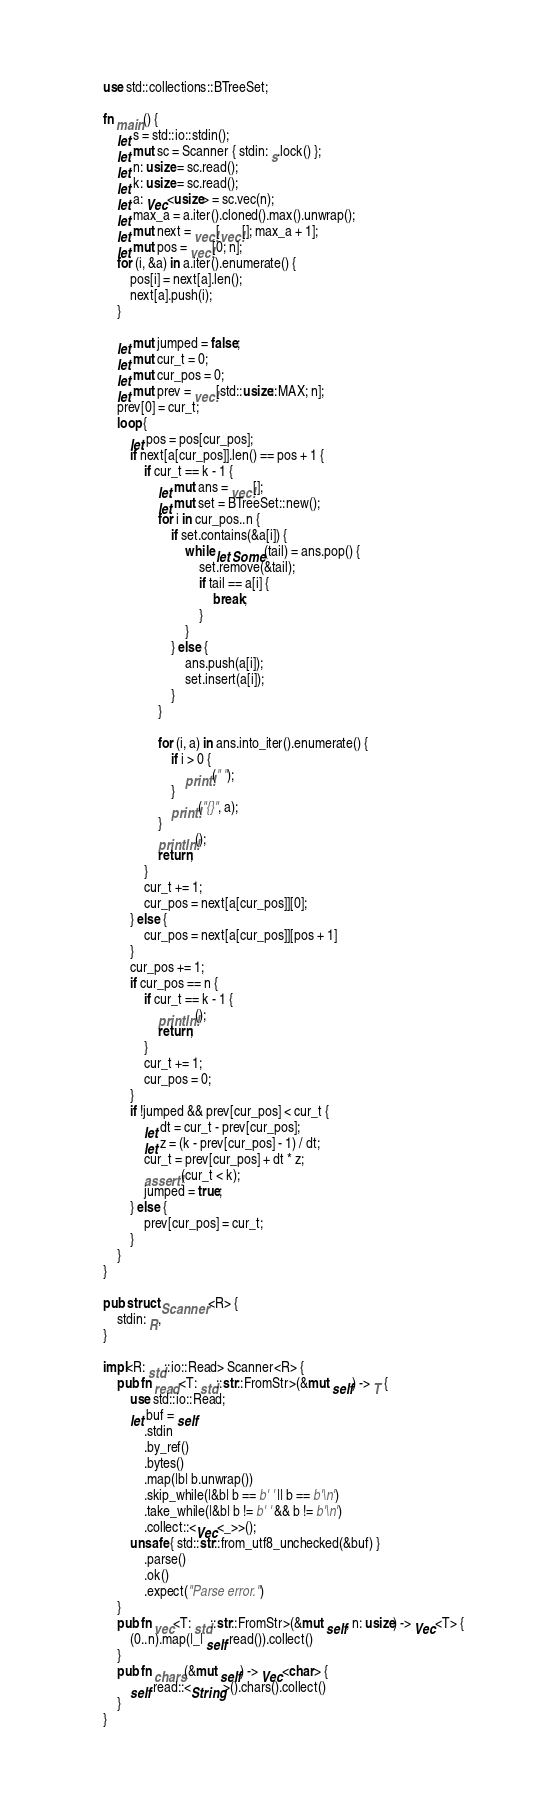Convert code to text. <code><loc_0><loc_0><loc_500><loc_500><_Rust_>use std::collections::BTreeSet;

fn main() {
    let s = std::io::stdin();
    let mut sc = Scanner { stdin: s.lock() };
    let n: usize = sc.read();
    let k: usize = sc.read();
    let a: Vec<usize> = sc.vec(n);
    let max_a = a.iter().cloned().max().unwrap();
    let mut next = vec![vec![]; max_a + 1];
    let mut pos = vec![0; n];
    for (i, &a) in a.iter().enumerate() {
        pos[i] = next[a].len();
        next[a].push(i);
    }

    let mut jumped = false;
    let mut cur_t = 0;
    let mut cur_pos = 0;
    let mut prev = vec![std::usize::MAX; n];
    prev[0] = cur_t;
    loop {
        let pos = pos[cur_pos];
        if next[a[cur_pos]].len() == pos + 1 {
            if cur_t == k - 1 {
                let mut ans = vec![];
                let mut set = BTreeSet::new();
                for i in cur_pos..n {
                    if set.contains(&a[i]) {
                        while let Some(tail) = ans.pop() {
                            set.remove(&tail);
                            if tail == a[i] {
                                break;
                            }
                        }
                    } else {
                        ans.push(a[i]);
                        set.insert(a[i]);
                    }
                }

                for (i, a) in ans.into_iter().enumerate() {
                    if i > 0 {
                        print!(" ");
                    }
                    print!("{}", a);
                }
                println!();
                return;
            }
            cur_t += 1;
            cur_pos = next[a[cur_pos]][0];
        } else {
            cur_pos = next[a[cur_pos]][pos + 1]
        }
        cur_pos += 1;
        if cur_pos == n {
            if cur_t == k - 1 {
                println!();
                return;
            }
            cur_t += 1;
            cur_pos = 0;
        }
        if !jumped && prev[cur_pos] < cur_t {
            let dt = cur_t - prev[cur_pos];
            let z = (k - prev[cur_pos] - 1) / dt;
            cur_t = prev[cur_pos] + dt * z;
            assert!(cur_t < k);
            jumped = true;
        } else {
            prev[cur_pos] = cur_t;
        }
    }
}

pub struct Scanner<R> {
    stdin: R,
}

impl<R: std::io::Read> Scanner<R> {
    pub fn read<T: std::str::FromStr>(&mut self) -> T {
        use std::io::Read;
        let buf = self
            .stdin
            .by_ref()
            .bytes()
            .map(|b| b.unwrap())
            .skip_while(|&b| b == b' ' || b == b'\n')
            .take_while(|&b| b != b' ' && b != b'\n')
            .collect::<Vec<_>>();
        unsafe { std::str::from_utf8_unchecked(&buf) }
            .parse()
            .ok()
            .expect("Parse error.")
    }
    pub fn vec<T: std::str::FromStr>(&mut self, n: usize) -> Vec<T> {
        (0..n).map(|_| self.read()).collect()
    }
    pub fn chars(&mut self) -> Vec<char> {
        self.read::<String>().chars().collect()
    }
}
</code> 